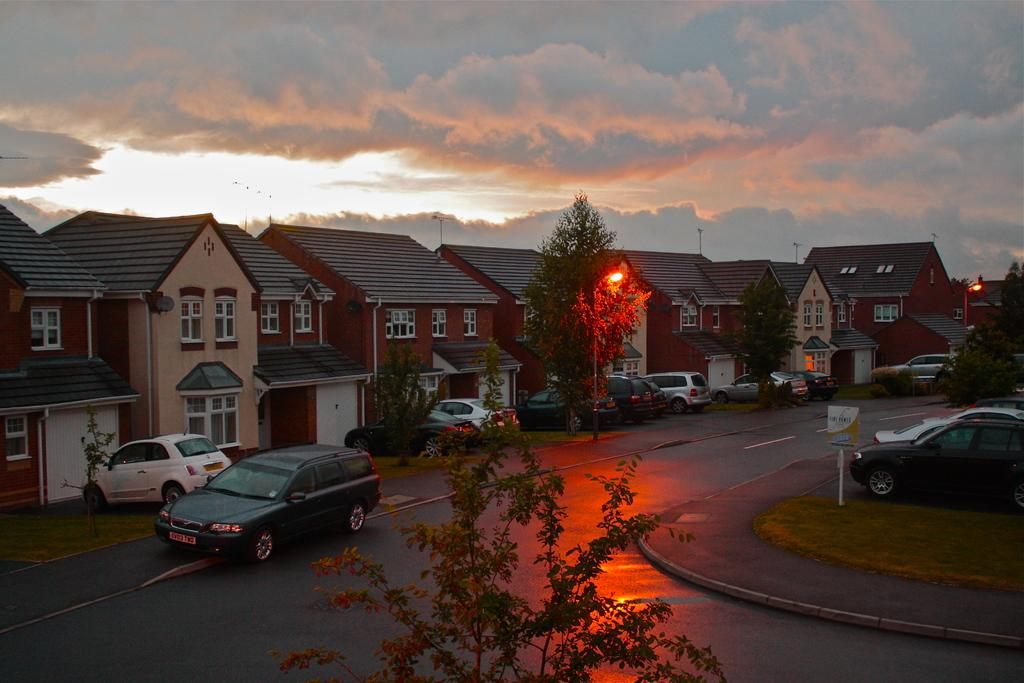What can be seen on the road in the image? There are vehicles on the road in the image. What type of structures are visible in the image? There are houses in the image. What natural elements are present in the image? There are trees in the image. What type of lighting is present in the image? There are street lights in the image. Can you describe any other objects in the image? There are other objects in the image, but their specific details are not mentioned in the provided facts. What is visible in the background of the image? The sky is visible in the background of the image. Can you see a boat sailing in the sky in the image? No, there is no boat sailing in the sky in the image. What type of sponge is being used to clean the windows of the houses in the image? There is no sponge visible in the image, and the windows of the houses are not being cleaned. 